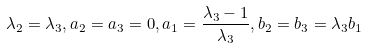<formula> <loc_0><loc_0><loc_500><loc_500>\lambda _ { 2 } = \lambda _ { 3 } , a _ { 2 } = a _ { 3 } = 0 , a _ { 1 } = \frac { \lambda _ { 3 } - 1 } { \lambda _ { 3 } } , b _ { 2 } = b _ { 3 } = \lambda _ { 3 } b _ { 1 }</formula> 